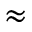Convert formula to latex. <formula><loc_0><loc_0><loc_500><loc_500>\approx</formula> 